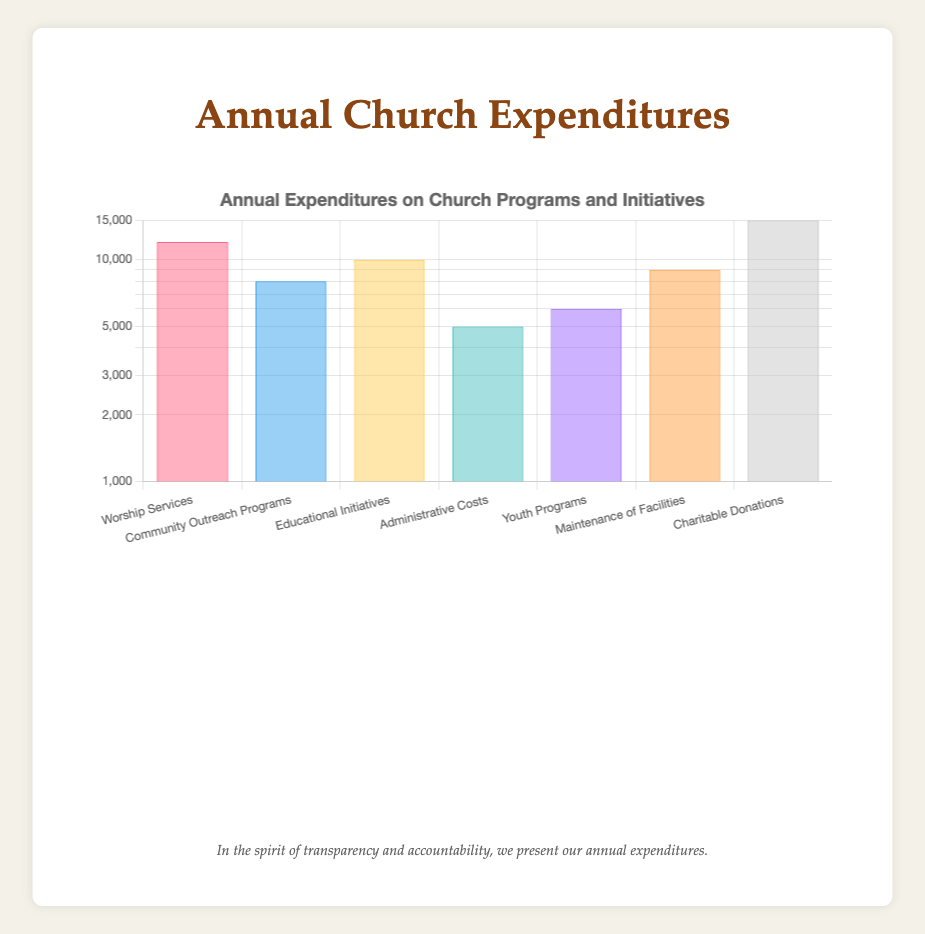What is the total amount spent on all programs and initiatives? To find the total amount, I will sum up all the expenditures listed in the table. Adding them together: 12000 + 8000 + 10000 + 5000 + 6000 + 9000 + 15000 gives us a total of 60000.
Answer: 60000 Which program had the highest expenditure? By reviewing the expenditures listed, I see that "Charitable Donations" has the highest amount of 15000, which is greater than all the other categories.
Answer: Charitable Donations What is the average annual expenditure on church programs? To find the average, I sum all expenditures to get 60000. There are 7 different categories, so I will divide the total by 7. Doing the calculation: 60000 / 7 gives approximately 8571.43.
Answer: 8571.43 Are the expenditures on Educational Initiatives greater than those on Youth Programs? I will compare the amounts in the relevant categories, which are 10000 for Educational Initiatives and 6000 for Youth Programs. Since 10000 is greater than 6000, the statement is true.
Answer: Yes What is the difference in expenditures between Worship Services and Administrative Costs? Worship Services amount to 12000 and Administrative Costs to 5000. To find the difference, I subtract the lower amount from the higher amount: 12000 - 5000 = 7000.
Answer: 7000 Which program has the lowest expenditure? Looking at the table, I see that "Administrative Costs" has the lowest amount, which is 5000, as it is the smallest figure when compared to all other categories.
Answer: Administrative Costs If we combine the expenditures for Community Outreach Programs and Youth Programs, what would be their total? The amounts for these programs are 8000 and 6000, respectively. I will sum these amounts: 8000 + 6000 = 14000, giving the combined total.
Answer: 14000 Is it true that the total spent on Maintenance of Facilities and Youth Programs exceeds the amount spent on Worship Services? First, I add the amounts for Maintenance of Facilities (9000) and Youth Programs (6000), giving me a total of 15000. Now, I compare this to Worship Services, which costs 12000. Since 15000 is greater than 12000, the statement is true.
Answer: Yes What percentage of the total expenditures do Administrative Costs represent? First, I recognize the total expenditures are 60000 and Administrative Costs are 5000. To find the percentage, I calculate (5000 / 60000) * 100, which equals approximately 8.33%.
Answer: 8.33% 